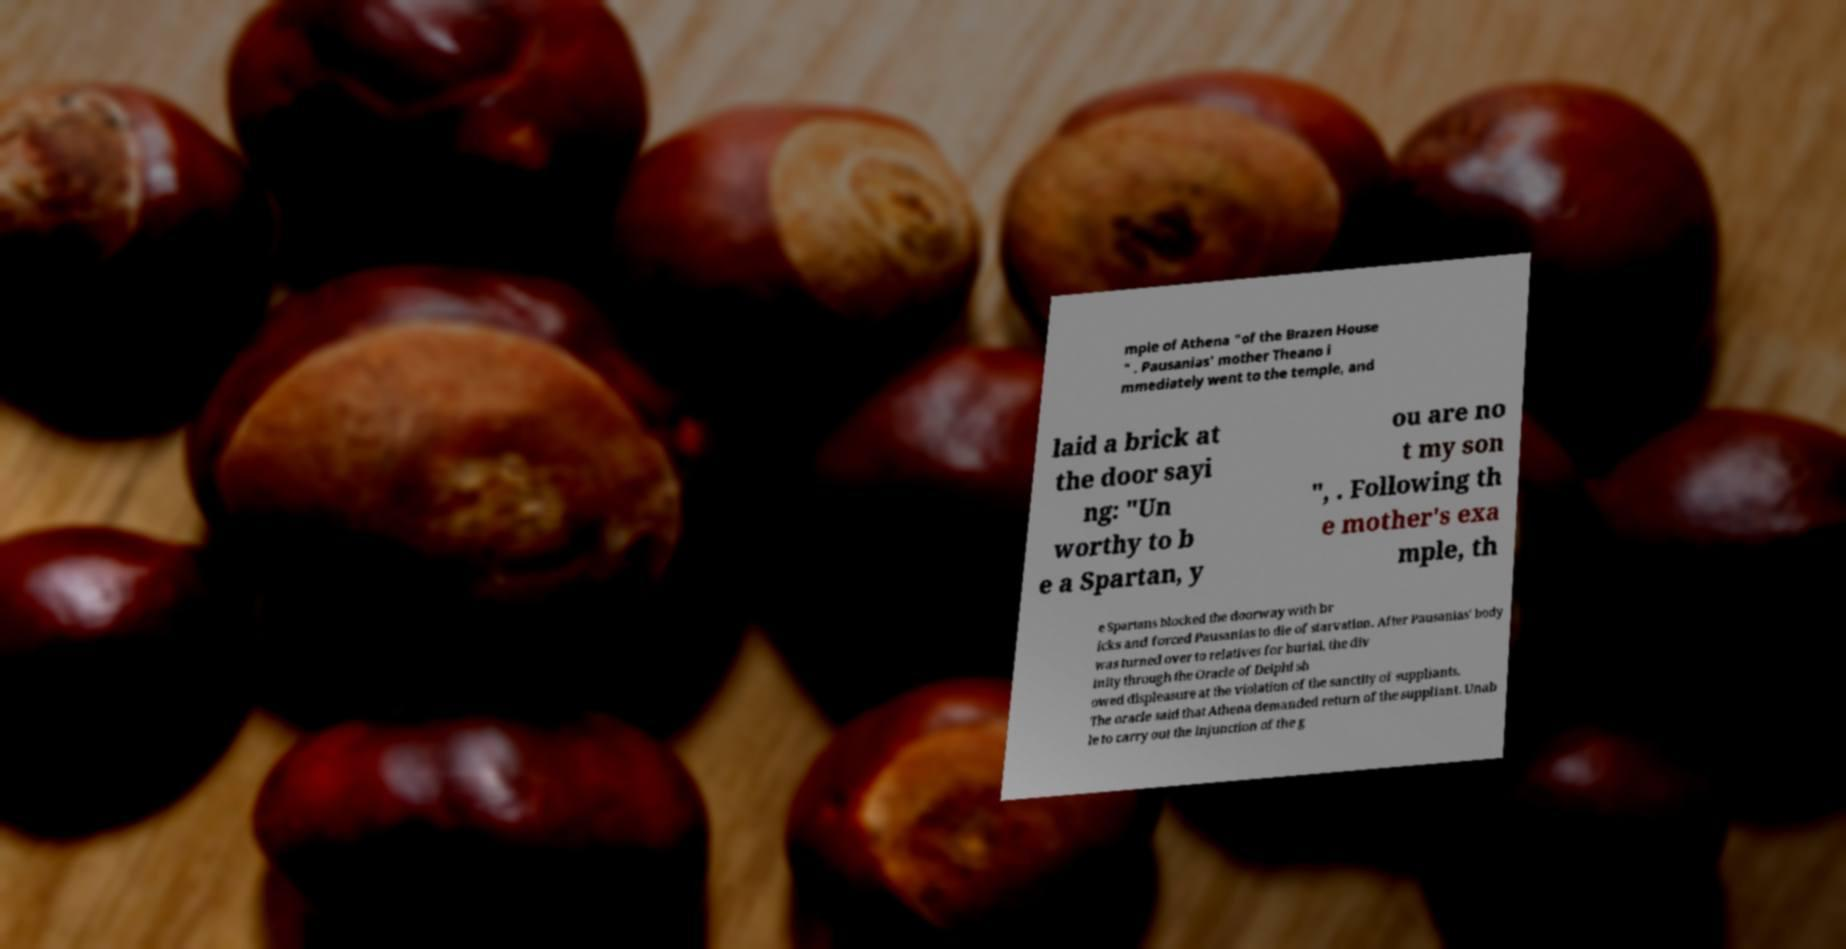I need the written content from this picture converted into text. Can you do that? mple of Athena "of the Brazen House " . Pausanias' mother Theano i mmediately went to the temple, and laid a brick at the door sayi ng: "Un worthy to b e a Spartan, y ou are no t my son ", . Following th e mother's exa mple, th e Spartans blocked the doorway with br icks and forced Pausanias to die of starvation. After Pausanias' body was turned over to relatives for burial, the div inity through the Oracle of Delphi sh owed displeasure at the violation of the sanctity of suppliants. The oracle said that Athena demanded return of the suppliant. Unab le to carry out the injunction of the g 